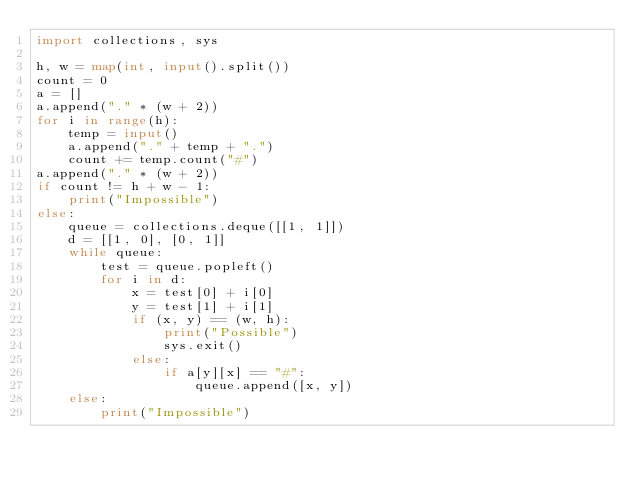<code> <loc_0><loc_0><loc_500><loc_500><_Python_>import collections, sys

h, w = map(int, input().split())
count = 0
a = []
a.append("." * (w + 2))
for i in range(h):
    temp = input()
    a.append("." + temp + ".")
    count += temp.count("#")
a.append("." * (w + 2))
if count != h + w - 1:
    print("Impossible")
else:
    queue = collections.deque([[1, 1]])
    d = [[1, 0], [0, 1]]
    while queue:
        test = queue.popleft()
        for i in d:
            x = test[0] + i[0]
            y = test[1] + i[1]
            if (x, y) == (w, h):
                print("Possible")
                sys.exit()
            else:
                if a[y][x] == "#":
                    queue.append([x, y])
    else:
        print("Impossible")</code> 